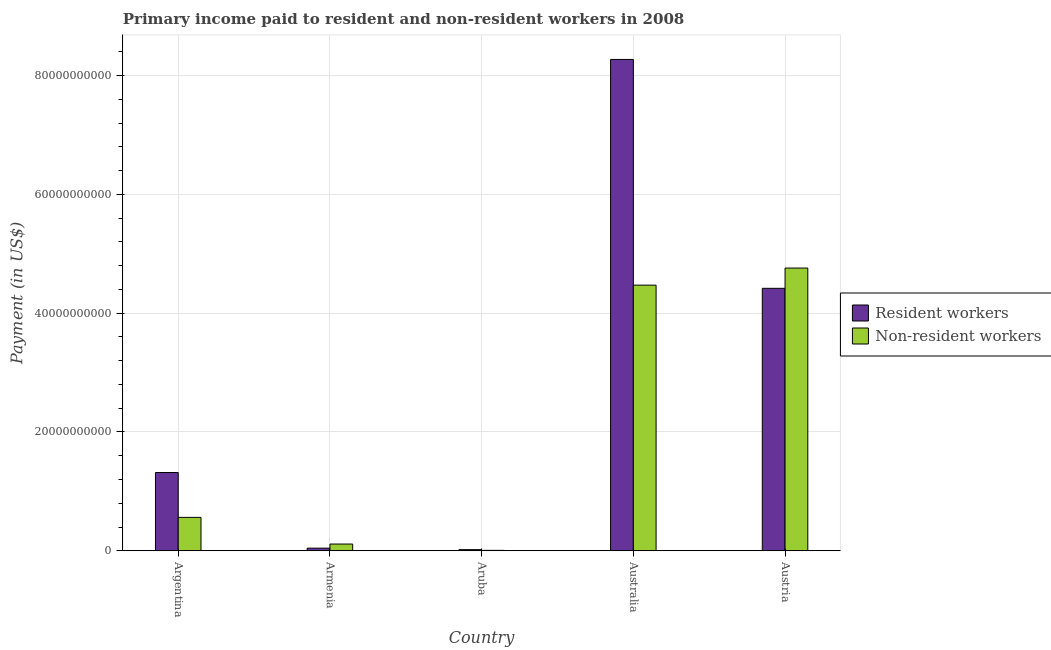Are the number of bars on each tick of the X-axis equal?
Your answer should be compact. Yes. What is the label of the 3rd group of bars from the left?
Offer a terse response. Aruba. What is the payment made to non-resident workers in Austria?
Offer a terse response. 4.76e+1. Across all countries, what is the maximum payment made to resident workers?
Provide a succinct answer. 8.27e+1. Across all countries, what is the minimum payment made to non-resident workers?
Keep it short and to the point. 7.18e+07. In which country was the payment made to non-resident workers maximum?
Keep it short and to the point. Austria. In which country was the payment made to resident workers minimum?
Your answer should be very brief. Aruba. What is the total payment made to resident workers in the graph?
Provide a short and direct response. 1.41e+11. What is the difference between the payment made to resident workers in Aruba and that in Australia?
Your response must be concise. -8.25e+1. What is the difference between the payment made to non-resident workers in Argentina and the payment made to resident workers in Austria?
Offer a terse response. -3.86e+1. What is the average payment made to resident workers per country?
Provide a succinct answer. 2.81e+1. What is the difference between the payment made to resident workers and payment made to non-resident workers in Australia?
Provide a short and direct response. 3.80e+1. What is the ratio of the payment made to non-resident workers in Argentina to that in Australia?
Provide a short and direct response. 0.13. Is the payment made to non-resident workers in Argentina less than that in Austria?
Offer a very short reply. Yes. What is the difference between the highest and the second highest payment made to non-resident workers?
Your response must be concise. 2.88e+09. What is the difference between the highest and the lowest payment made to non-resident workers?
Make the answer very short. 4.75e+1. Is the sum of the payment made to non-resident workers in Argentina and Australia greater than the maximum payment made to resident workers across all countries?
Make the answer very short. No. What does the 1st bar from the left in Armenia represents?
Ensure brevity in your answer.  Resident workers. What does the 1st bar from the right in Aruba represents?
Offer a very short reply. Non-resident workers. How many bars are there?
Your response must be concise. 10. Are all the bars in the graph horizontal?
Make the answer very short. No. How many countries are there in the graph?
Provide a short and direct response. 5. Where does the legend appear in the graph?
Your response must be concise. Center right. What is the title of the graph?
Offer a very short reply. Primary income paid to resident and non-resident workers in 2008. Does "Under-5(female)" appear as one of the legend labels in the graph?
Offer a very short reply. No. What is the label or title of the X-axis?
Offer a terse response. Country. What is the label or title of the Y-axis?
Provide a succinct answer. Payment (in US$). What is the Payment (in US$) in Resident workers in Argentina?
Ensure brevity in your answer.  1.32e+1. What is the Payment (in US$) of Non-resident workers in Argentina?
Your answer should be compact. 5.62e+09. What is the Payment (in US$) in Resident workers in Armenia?
Offer a terse response. 4.42e+08. What is the Payment (in US$) in Non-resident workers in Armenia?
Your response must be concise. 1.13e+09. What is the Payment (in US$) of Resident workers in Aruba?
Offer a terse response. 1.89e+08. What is the Payment (in US$) in Non-resident workers in Aruba?
Offer a terse response. 7.18e+07. What is the Payment (in US$) in Resident workers in Australia?
Keep it short and to the point. 8.27e+1. What is the Payment (in US$) in Non-resident workers in Australia?
Your answer should be compact. 4.47e+1. What is the Payment (in US$) in Resident workers in Austria?
Your response must be concise. 4.42e+1. What is the Payment (in US$) of Non-resident workers in Austria?
Provide a succinct answer. 4.76e+1. Across all countries, what is the maximum Payment (in US$) of Resident workers?
Keep it short and to the point. 8.27e+1. Across all countries, what is the maximum Payment (in US$) of Non-resident workers?
Ensure brevity in your answer.  4.76e+1. Across all countries, what is the minimum Payment (in US$) in Resident workers?
Keep it short and to the point. 1.89e+08. Across all countries, what is the minimum Payment (in US$) in Non-resident workers?
Keep it short and to the point. 7.18e+07. What is the total Payment (in US$) of Resident workers in the graph?
Make the answer very short. 1.41e+11. What is the total Payment (in US$) of Non-resident workers in the graph?
Your answer should be very brief. 9.91e+1. What is the difference between the Payment (in US$) in Resident workers in Argentina and that in Armenia?
Your response must be concise. 1.27e+1. What is the difference between the Payment (in US$) of Non-resident workers in Argentina and that in Armenia?
Provide a succinct answer. 4.49e+09. What is the difference between the Payment (in US$) of Resident workers in Argentina and that in Aruba?
Your answer should be very brief. 1.30e+1. What is the difference between the Payment (in US$) of Non-resident workers in Argentina and that in Aruba?
Make the answer very short. 5.55e+09. What is the difference between the Payment (in US$) in Resident workers in Argentina and that in Australia?
Ensure brevity in your answer.  -6.95e+1. What is the difference between the Payment (in US$) of Non-resident workers in Argentina and that in Australia?
Ensure brevity in your answer.  -3.91e+1. What is the difference between the Payment (in US$) of Resident workers in Argentina and that in Austria?
Offer a very short reply. -3.10e+1. What is the difference between the Payment (in US$) in Non-resident workers in Argentina and that in Austria?
Your answer should be compact. -4.20e+1. What is the difference between the Payment (in US$) in Resident workers in Armenia and that in Aruba?
Make the answer very short. 2.53e+08. What is the difference between the Payment (in US$) in Non-resident workers in Armenia and that in Aruba?
Your response must be concise. 1.06e+09. What is the difference between the Payment (in US$) of Resident workers in Armenia and that in Australia?
Your answer should be compact. -8.23e+1. What is the difference between the Payment (in US$) of Non-resident workers in Armenia and that in Australia?
Your answer should be compact. -4.36e+1. What is the difference between the Payment (in US$) of Resident workers in Armenia and that in Austria?
Your response must be concise. -4.37e+1. What is the difference between the Payment (in US$) in Non-resident workers in Armenia and that in Austria?
Provide a succinct answer. -4.65e+1. What is the difference between the Payment (in US$) of Resident workers in Aruba and that in Australia?
Offer a very short reply. -8.25e+1. What is the difference between the Payment (in US$) in Non-resident workers in Aruba and that in Australia?
Keep it short and to the point. -4.46e+1. What is the difference between the Payment (in US$) in Resident workers in Aruba and that in Austria?
Ensure brevity in your answer.  -4.40e+1. What is the difference between the Payment (in US$) of Non-resident workers in Aruba and that in Austria?
Give a very brief answer. -4.75e+1. What is the difference between the Payment (in US$) of Resident workers in Australia and that in Austria?
Your answer should be very brief. 3.85e+1. What is the difference between the Payment (in US$) in Non-resident workers in Australia and that in Austria?
Ensure brevity in your answer.  -2.88e+09. What is the difference between the Payment (in US$) in Resident workers in Argentina and the Payment (in US$) in Non-resident workers in Armenia?
Ensure brevity in your answer.  1.20e+1. What is the difference between the Payment (in US$) in Resident workers in Argentina and the Payment (in US$) in Non-resident workers in Aruba?
Your answer should be compact. 1.31e+1. What is the difference between the Payment (in US$) in Resident workers in Argentina and the Payment (in US$) in Non-resident workers in Australia?
Offer a very short reply. -3.15e+1. What is the difference between the Payment (in US$) in Resident workers in Argentina and the Payment (in US$) in Non-resident workers in Austria?
Your answer should be compact. -3.44e+1. What is the difference between the Payment (in US$) of Resident workers in Armenia and the Payment (in US$) of Non-resident workers in Aruba?
Provide a short and direct response. 3.70e+08. What is the difference between the Payment (in US$) in Resident workers in Armenia and the Payment (in US$) in Non-resident workers in Australia?
Keep it short and to the point. -4.43e+1. What is the difference between the Payment (in US$) in Resident workers in Armenia and the Payment (in US$) in Non-resident workers in Austria?
Your response must be concise. -4.71e+1. What is the difference between the Payment (in US$) of Resident workers in Aruba and the Payment (in US$) of Non-resident workers in Australia?
Your response must be concise. -4.45e+1. What is the difference between the Payment (in US$) in Resident workers in Aruba and the Payment (in US$) in Non-resident workers in Austria?
Provide a short and direct response. -4.74e+1. What is the difference between the Payment (in US$) of Resident workers in Australia and the Payment (in US$) of Non-resident workers in Austria?
Offer a very short reply. 3.51e+1. What is the average Payment (in US$) of Resident workers per country?
Ensure brevity in your answer.  2.81e+1. What is the average Payment (in US$) of Non-resident workers per country?
Ensure brevity in your answer.  1.98e+1. What is the difference between the Payment (in US$) in Resident workers and Payment (in US$) in Non-resident workers in Argentina?
Keep it short and to the point. 7.55e+09. What is the difference between the Payment (in US$) of Resident workers and Payment (in US$) of Non-resident workers in Armenia?
Your answer should be very brief. -6.91e+08. What is the difference between the Payment (in US$) in Resident workers and Payment (in US$) in Non-resident workers in Aruba?
Your response must be concise. 1.17e+08. What is the difference between the Payment (in US$) in Resident workers and Payment (in US$) in Non-resident workers in Australia?
Ensure brevity in your answer.  3.80e+1. What is the difference between the Payment (in US$) of Resident workers and Payment (in US$) of Non-resident workers in Austria?
Offer a very short reply. -3.41e+09. What is the ratio of the Payment (in US$) of Resident workers in Argentina to that in Armenia?
Offer a very short reply. 29.8. What is the ratio of the Payment (in US$) in Non-resident workers in Argentina to that in Armenia?
Your answer should be very brief. 4.96. What is the ratio of the Payment (in US$) in Resident workers in Argentina to that in Aruba?
Make the answer very short. 69.86. What is the ratio of the Payment (in US$) of Non-resident workers in Argentina to that in Aruba?
Keep it short and to the point. 78.29. What is the ratio of the Payment (in US$) in Resident workers in Argentina to that in Australia?
Make the answer very short. 0.16. What is the ratio of the Payment (in US$) of Non-resident workers in Argentina to that in Australia?
Ensure brevity in your answer.  0.13. What is the ratio of the Payment (in US$) in Resident workers in Argentina to that in Austria?
Give a very brief answer. 0.3. What is the ratio of the Payment (in US$) in Non-resident workers in Argentina to that in Austria?
Offer a very short reply. 0.12. What is the ratio of the Payment (in US$) of Resident workers in Armenia to that in Aruba?
Make the answer very short. 2.34. What is the ratio of the Payment (in US$) of Non-resident workers in Armenia to that in Aruba?
Provide a succinct answer. 15.79. What is the ratio of the Payment (in US$) of Resident workers in Armenia to that in Australia?
Offer a terse response. 0.01. What is the ratio of the Payment (in US$) in Non-resident workers in Armenia to that in Australia?
Make the answer very short. 0.03. What is the ratio of the Payment (in US$) in Non-resident workers in Armenia to that in Austria?
Keep it short and to the point. 0.02. What is the ratio of the Payment (in US$) of Resident workers in Aruba to that in Australia?
Your answer should be compact. 0. What is the ratio of the Payment (in US$) in Non-resident workers in Aruba to that in Australia?
Your answer should be very brief. 0. What is the ratio of the Payment (in US$) of Resident workers in Aruba to that in Austria?
Offer a very short reply. 0. What is the ratio of the Payment (in US$) in Non-resident workers in Aruba to that in Austria?
Your answer should be very brief. 0. What is the ratio of the Payment (in US$) of Resident workers in Australia to that in Austria?
Offer a very short reply. 1.87. What is the ratio of the Payment (in US$) of Non-resident workers in Australia to that in Austria?
Provide a succinct answer. 0.94. What is the difference between the highest and the second highest Payment (in US$) in Resident workers?
Your answer should be compact. 3.85e+1. What is the difference between the highest and the second highest Payment (in US$) of Non-resident workers?
Offer a very short reply. 2.88e+09. What is the difference between the highest and the lowest Payment (in US$) of Resident workers?
Offer a terse response. 8.25e+1. What is the difference between the highest and the lowest Payment (in US$) in Non-resident workers?
Keep it short and to the point. 4.75e+1. 